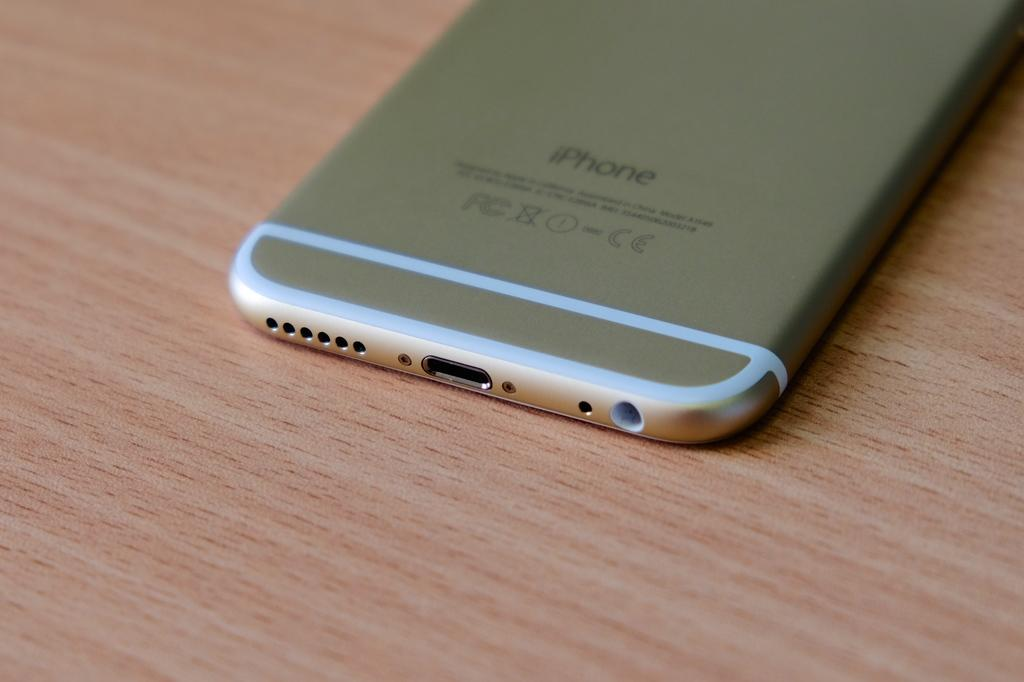<image>
Summarize the visual content of the image. An iPhone branded cellular phone sitting on a table. 